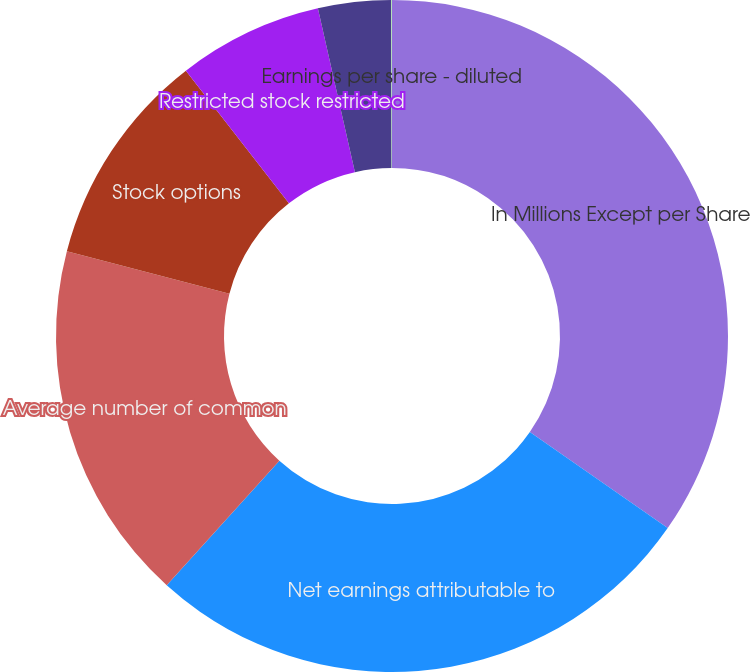Convert chart. <chart><loc_0><loc_0><loc_500><loc_500><pie_chart><fcel>In Millions Except per Share<fcel>Net earnings attributable to<fcel>Average number of common<fcel>Stock options<fcel>Restricted stock restricted<fcel>Earnings per share - basic<fcel>Earnings per share - diluted<nl><fcel>34.68%<fcel>27.01%<fcel>17.36%<fcel>10.43%<fcel>6.97%<fcel>3.5%<fcel>0.04%<nl></chart> 